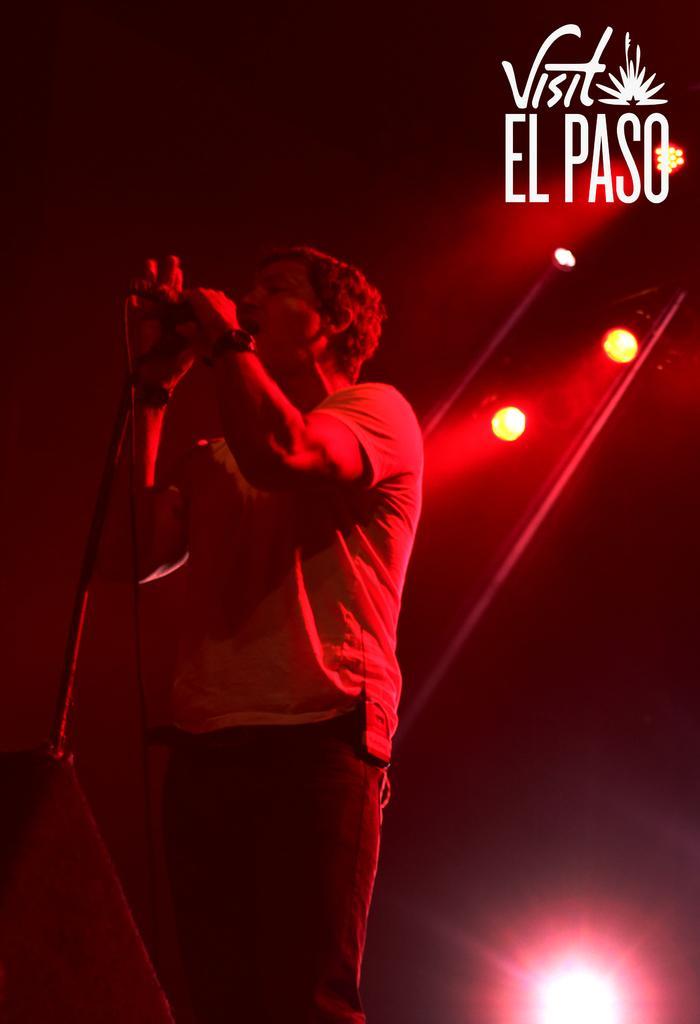Could you give a brief overview of what you see in this image? In this picture we can see a person standing and holding a mike, behind we can see some lights, we can see some text. 